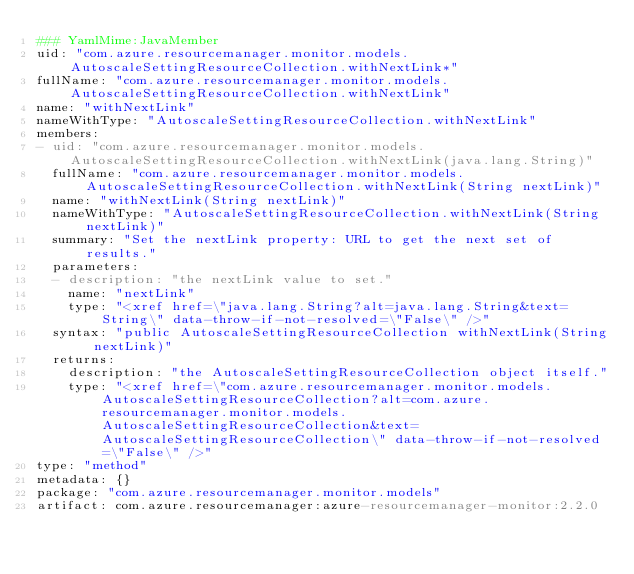<code> <loc_0><loc_0><loc_500><loc_500><_YAML_>### YamlMime:JavaMember
uid: "com.azure.resourcemanager.monitor.models.AutoscaleSettingResourceCollection.withNextLink*"
fullName: "com.azure.resourcemanager.monitor.models.AutoscaleSettingResourceCollection.withNextLink"
name: "withNextLink"
nameWithType: "AutoscaleSettingResourceCollection.withNextLink"
members:
- uid: "com.azure.resourcemanager.monitor.models.AutoscaleSettingResourceCollection.withNextLink(java.lang.String)"
  fullName: "com.azure.resourcemanager.monitor.models.AutoscaleSettingResourceCollection.withNextLink(String nextLink)"
  name: "withNextLink(String nextLink)"
  nameWithType: "AutoscaleSettingResourceCollection.withNextLink(String nextLink)"
  summary: "Set the nextLink property: URL to get the next set of results."
  parameters:
  - description: "the nextLink value to set."
    name: "nextLink"
    type: "<xref href=\"java.lang.String?alt=java.lang.String&text=String\" data-throw-if-not-resolved=\"False\" />"
  syntax: "public AutoscaleSettingResourceCollection withNextLink(String nextLink)"
  returns:
    description: "the AutoscaleSettingResourceCollection object itself."
    type: "<xref href=\"com.azure.resourcemanager.monitor.models.AutoscaleSettingResourceCollection?alt=com.azure.resourcemanager.monitor.models.AutoscaleSettingResourceCollection&text=AutoscaleSettingResourceCollection\" data-throw-if-not-resolved=\"False\" />"
type: "method"
metadata: {}
package: "com.azure.resourcemanager.monitor.models"
artifact: com.azure.resourcemanager:azure-resourcemanager-monitor:2.2.0
</code> 